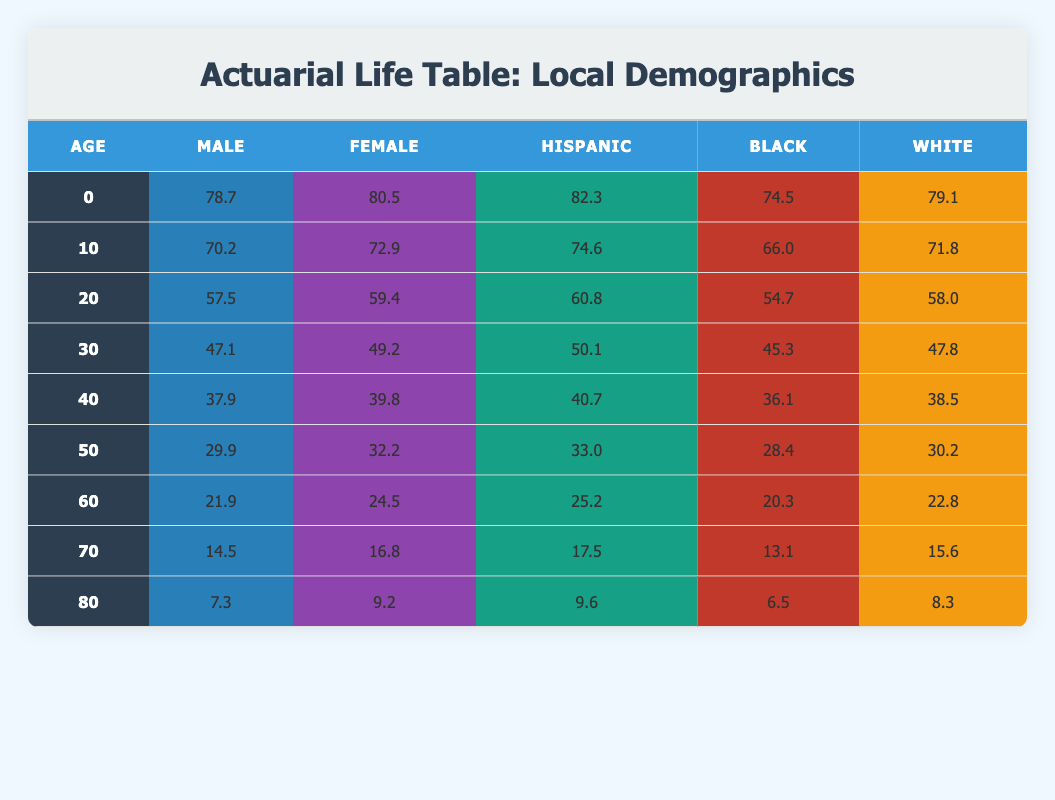What is the life expectancy for a 60-year-old male? Looking at the row for age 60 in the male column, the life expectancy is indicated as 21.9.
Answer: 21.9 What is the life expectancy for a 50-year-old black individual? Referring to the row for age 50 in the black column, the life expectancy is listed as 28.4.
Answer: 28.4 Is the life expectancy for Hispanic females higher than for white females at the age of 40? The life expectancy for Hispanic females at age 40 is 40.7, while for white females, it is 39.8. Since 40.7 is greater than 39.8, the statement is true.
Answer: Yes What is the difference in life expectancy between 70-year-old females and 70-year-old males? For 70-year-old females, the life expectancy is 16.8, and for 70-year-old males, it is 14.5. The difference is calculated as 16.8 - 14.5 = 2.3.
Answer: 2.3 What is the average life expectancy for a 20-year-old across all demographics? For age 20, the life expectancies are 57.5 (male), 59.4 (female), 60.8 (Hispanic), 54.7 (black), and 58.0 (white). Adding them up gives 57.5 + 59.4 + 60.8 + 54.7 + 58.0 = 290.4. There are 5 demographics, so the average is 290.4 / 5 = 58.08.
Answer: 58.08 Is it true that the life expectancy for females is consistently higher than that for males across all ages? By comparing the life expectancy values for females and males at each of the ages in the table, we find that females consistently have higher values than males, confirming the statement is true.
Answer: Yes 